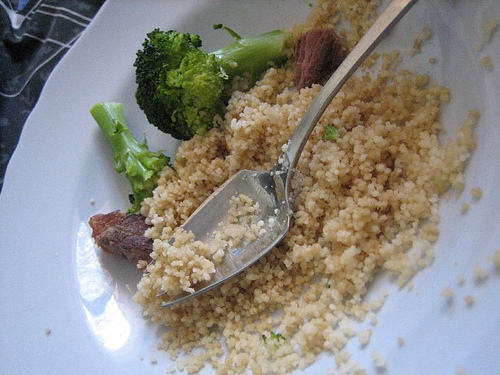<image>What sort of rice is shown? I don't know what sort of rice is shown. It can be quinoa, brown rice, pilaf, fried or couscous. What sort of rice is shown? I don't know what sort of rice is shown. It can be either quinoa, brown rice, pilaf or fried rice. 